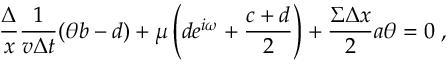Convert formula to latex. <formula><loc_0><loc_0><loc_500><loc_500>\frac { \Delta } { x } \frac { 1 } { v \Delta t } ( \theta b - d ) + \mu \left ( d e ^ { i \omega } + \frac { c + d } { 2 } \right ) + \frac { \Sigma \Delta x } { 2 } a \theta = 0 \, ,</formula> 